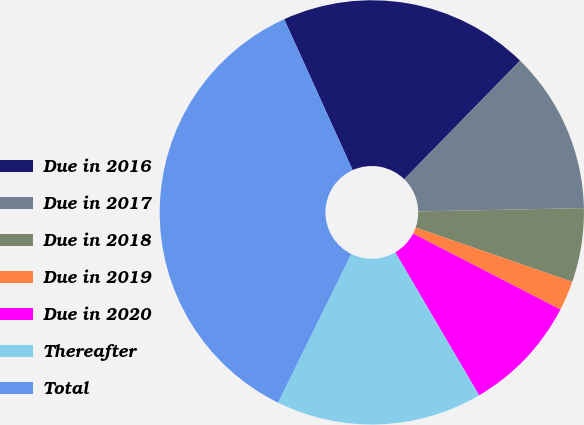Convert chart. <chart><loc_0><loc_0><loc_500><loc_500><pie_chart><fcel>Due in 2016<fcel>Due in 2017<fcel>Due in 2018<fcel>Due in 2019<fcel>Due in 2020<fcel>Thereafter<fcel>Total<nl><fcel>19.1%<fcel>12.36%<fcel>5.63%<fcel>2.26%<fcel>8.99%<fcel>15.73%<fcel>35.93%<nl></chart> 